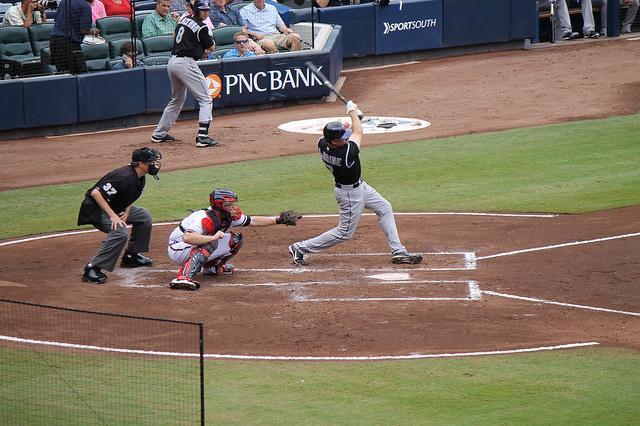How many people can be seen?
Give a very brief answer. 6. How many horses are there?
Give a very brief answer. 0. 